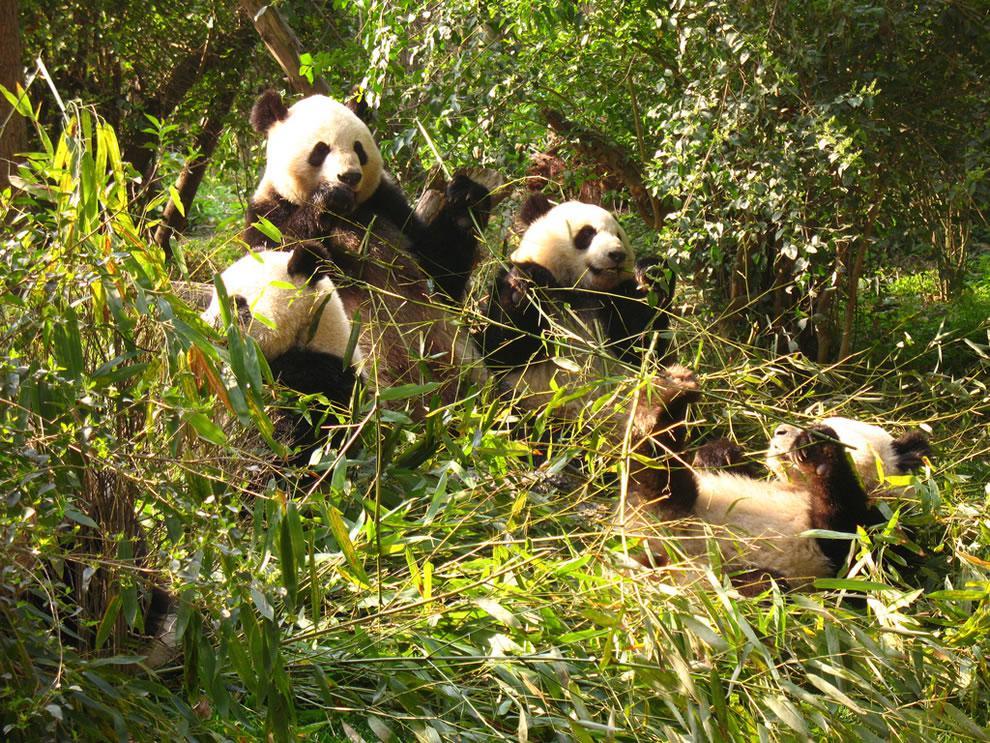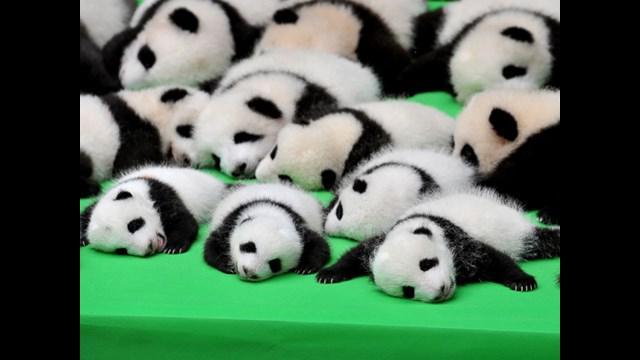The first image is the image on the left, the second image is the image on the right. Analyze the images presented: Is the assertion "There are at most 5 pandas in the image pair." valid? Answer yes or no. No. The first image is the image on the left, the second image is the image on the right. Analyze the images presented: Is the assertion "One image shows multiple pandas sitting in a group chewing on stalks, and the other includes a panda with its arms flung wide." valid? Answer yes or no. Yes. 